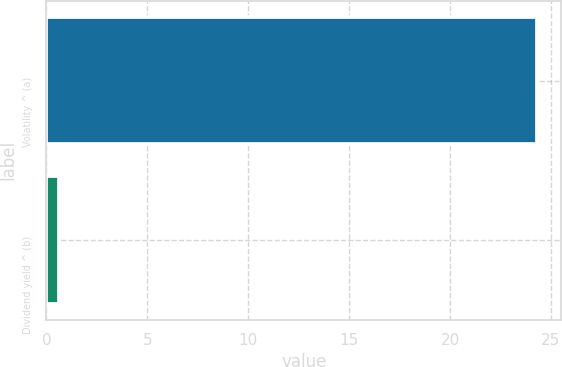Convert chart. <chart><loc_0><loc_0><loc_500><loc_500><bar_chart><fcel>Volatility ^ (a)<fcel>Dividend yield ^ (b)<nl><fcel>24.3<fcel>0.6<nl></chart> 